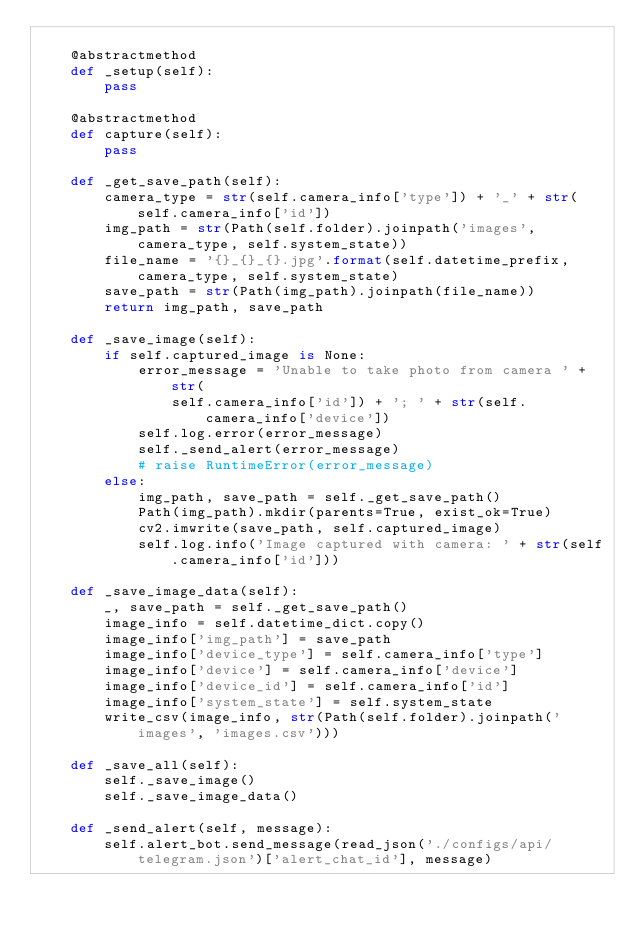Convert code to text. <code><loc_0><loc_0><loc_500><loc_500><_Python_>
    @abstractmethod
    def _setup(self):
        pass

    @abstractmethod
    def capture(self):
        pass

    def _get_save_path(self):
        camera_type = str(self.camera_info['type']) + '_' + str(self.camera_info['id'])
        img_path = str(Path(self.folder).joinpath('images', camera_type, self.system_state))
        file_name = '{}_{}_{}.jpg'.format(self.datetime_prefix, camera_type, self.system_state)
        save_path = str(Path(img_path).joinpath(file_name))
        return img_path, save_path

    def _save_image(self):
        if self.captured_image is None:
            error_message = 'Unable to take photo from camera ' + str(
                self.camera_info['id']) + '; ' + str(self.camera_info['device'])
            self.log.error(error_message)
            self._send_alert(error_message)
            # raise RuntimeError(error_message)
        else:
            img_path, save_path = self._get_save_path()
            Path(img_path).mkdir(parents=True, exist_ok=True)
            cv2.imwrite(save_path, self.captured_image)
            self.log.info('Image captured with camera: ' + str(self.camera_info['id']))

    def _save_image_data(self):
        _, save_path = self._get_save_path()
        image_info = self.datetime_dict.copy()
        image_info['img_path'] = save_path
        image_info['device_type'] = self.camera_info['type']
        image_info['device'] = self.camera_info['device']
        image_info['device_id'] = self.camera_info['id']
        image_info['system_state'] = self.system_state
        write_csv(image_info, str(Path(self.folder).joinpath('images', 'images.csv')))

    def _save_all(self):
        self._save_image()
        self._save_image_data()

    def _send_alert(self, message):
        self.alert_bot.send_message(read_json('./configs/api/telegram.json')['alert_chat_id'], message)
</code> 